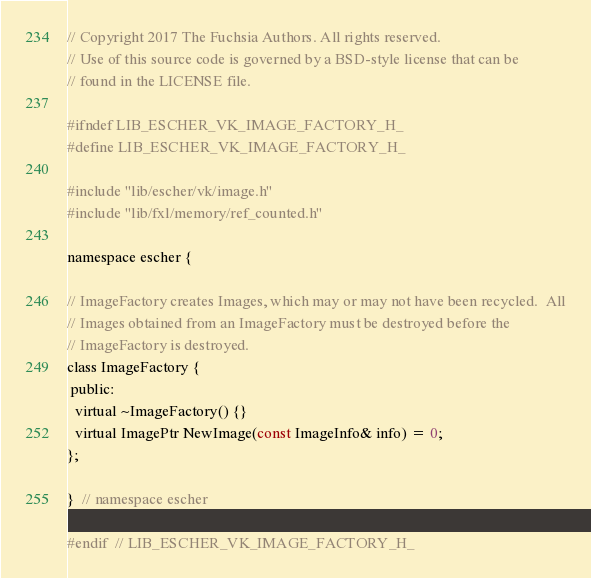<code> <loc_0><loc_0><loc_500><loc_500><_C_>// Copyright 2017 The Fuchsia Authors. All rights reserved.
// Use of this source code is governed by a BSD-style license that can be
// found in the LICENSE file.

#ifndef LIB_ESCHER_VK_IMAGE_FACTORY_H_
#define LIB_ESCHER_VK_IMAGE_FACTORY_H_

#include "lib/escher/vk/image.h"
#include "lib/fxl/memory/ref_counted.h"

namespace escher {

// ImageFactory creates Images, which may or may not have been recycled.  All
// Images obtained from an ImageFactory must be destroyed before the
// ImageFactory is destroyed.
class ImageFactory {
 public:
  virtual ~ImageFactory() {}
  virtual ImagePtr NewImage(const ImageInfo& info) = 0;
};

}  // namespace escher

#endif  // LIB_ESCHER_VK_IMAGE_FACTORY_H_
</code> 